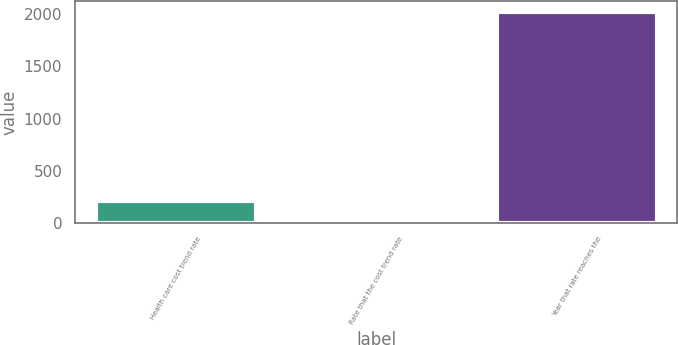<chart> <loc_0><loc_0><loc_500><loc_500><bar_chart><fcel>Health care cost trend rate<fcel>Rate that the cost trend rate<fcel>Year that rate reaches the<nl><fcel>207<fcel>5<fcel>2025<nl></chart> 